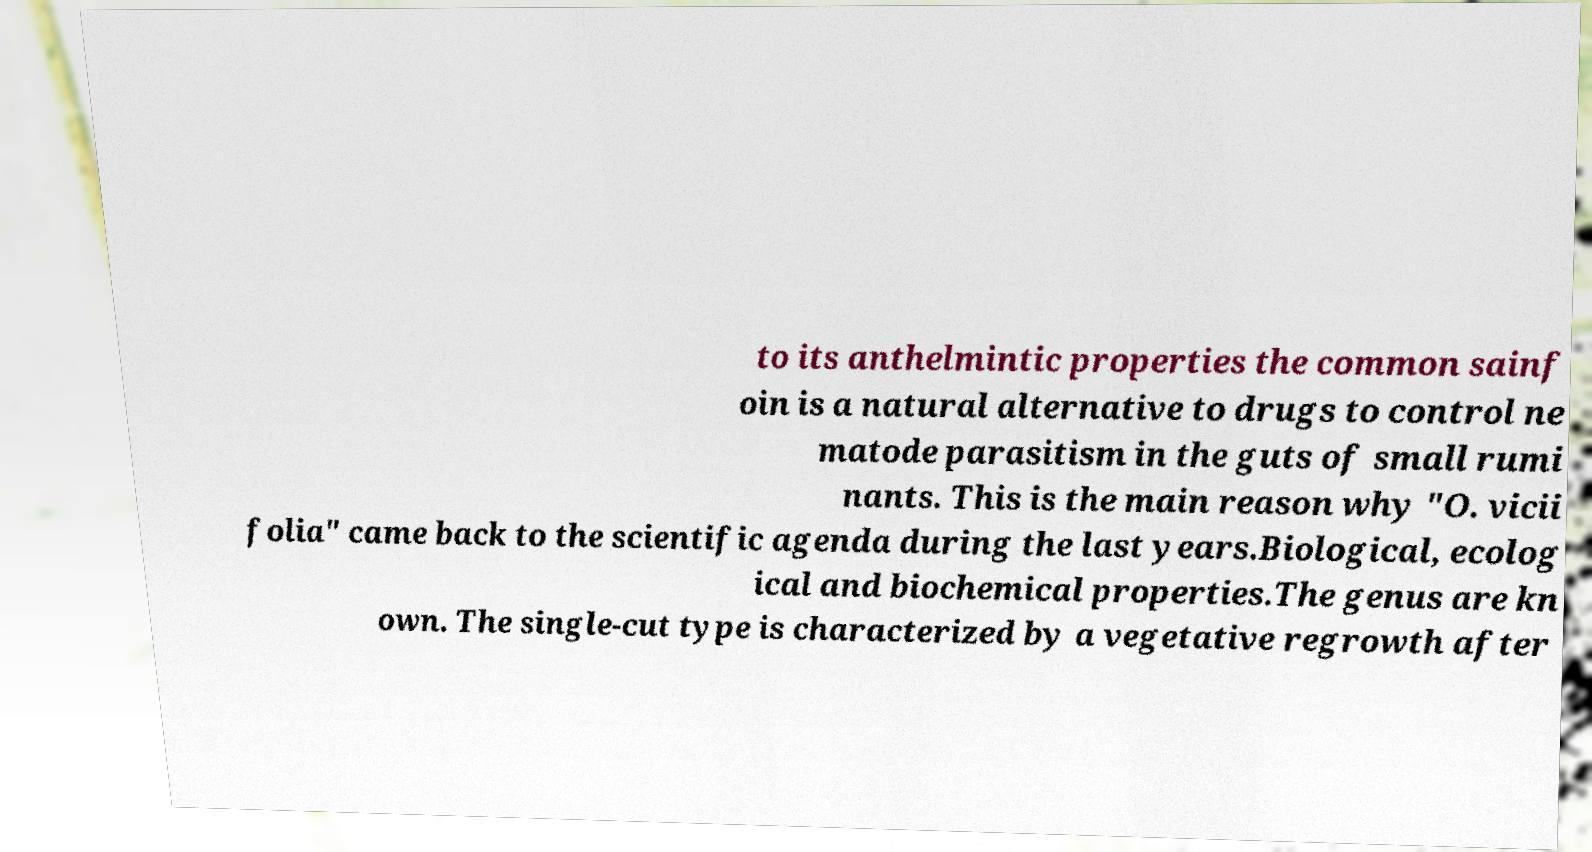Please identify and transcribe the text found in this image. to its anthelmintic properties the common sainf oin is a natural alternative to drugs to control ne matode parasitism in the guts of small rumi nants. This is the main reason why "O. vicii folia" came back to the scientific agenda during the last years.Biological, ecolog ical and biochemical properties.The genus are kn own. The single-cut type is characterized by a vegetative regrowth after 